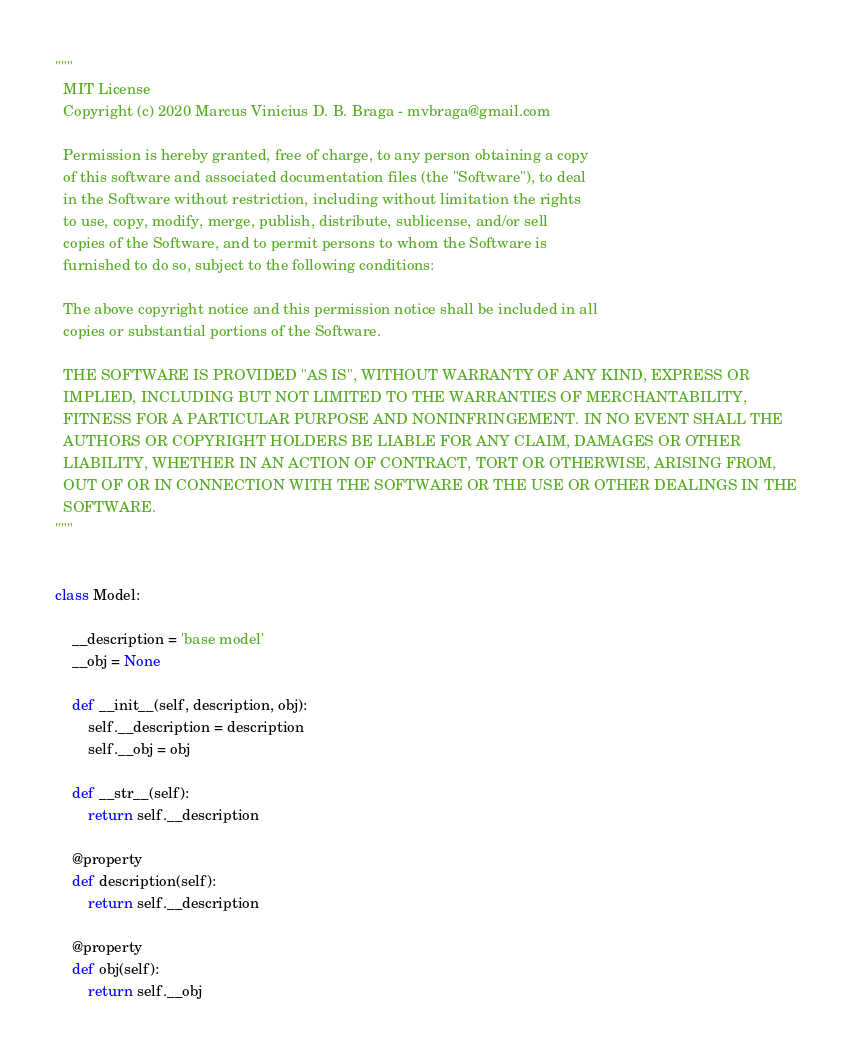Convert code to text. <code><loc_0><loc_0><loc_500><loc_500><_Python_>"""
  MIT License
  Copyright (c) 2020 Marcus Vinicius D. B. Braga - mvbraga@gmail.com

  Permission is hereby granted, free of charge, to any person obtaining a copy
  of this software and associated documentation files (the "Software"), to deal
  in the Software without restriction, including without limitation the rights
  to use, copy, modify, merge, publish, distribute, sublicense, and/or sell
  copies of the Software, and to permit persons to whom the Software is
  furnished to do so, subject to the following conditions:

  The above copyright notice and this permission notice shall be included in all
  copies or substantial portions of the Software.

  THE SOFTWARE IS PROVIDED "AS IS", WITHOUT WARRANTY OF ANY KIND, EXPRESS OR
  IMPLIED, INCLUDING BUT NOT LIMITED TO THE WARRANTIES OF MERCHANTABILITY,
  FITNESS FOR A PARTICULAR PURPOSE AND NONINFRINGEMENT. IN NO EVENT SHALL THE
  AUTHORS OR COPYRIGHT HOLDERS BE LIABLE FOR ANY CLAIM, DAMAGES OR OTHER
  LIABILITY, WHETHER IN AN ACTION OF CONTRACT, TORT OR OTHERWISE, ARISING FROM,
  OUT OF OR IN CONNECTION WITH THE SOFTWARE OR THE USE OR OTHER DEALINGS IN THE
  SOFTWARE.
"""


class Model:

    __description = 'base model'
    __obj = None

    def __init__(self, description, obj):
        self.__description = description
        self.__obj = obj

    def __str__(self):
        return self.__description

    @property
    def description(self):
        return self.__description

    @property
    def obj(self):
        return self.__obj
</code> 